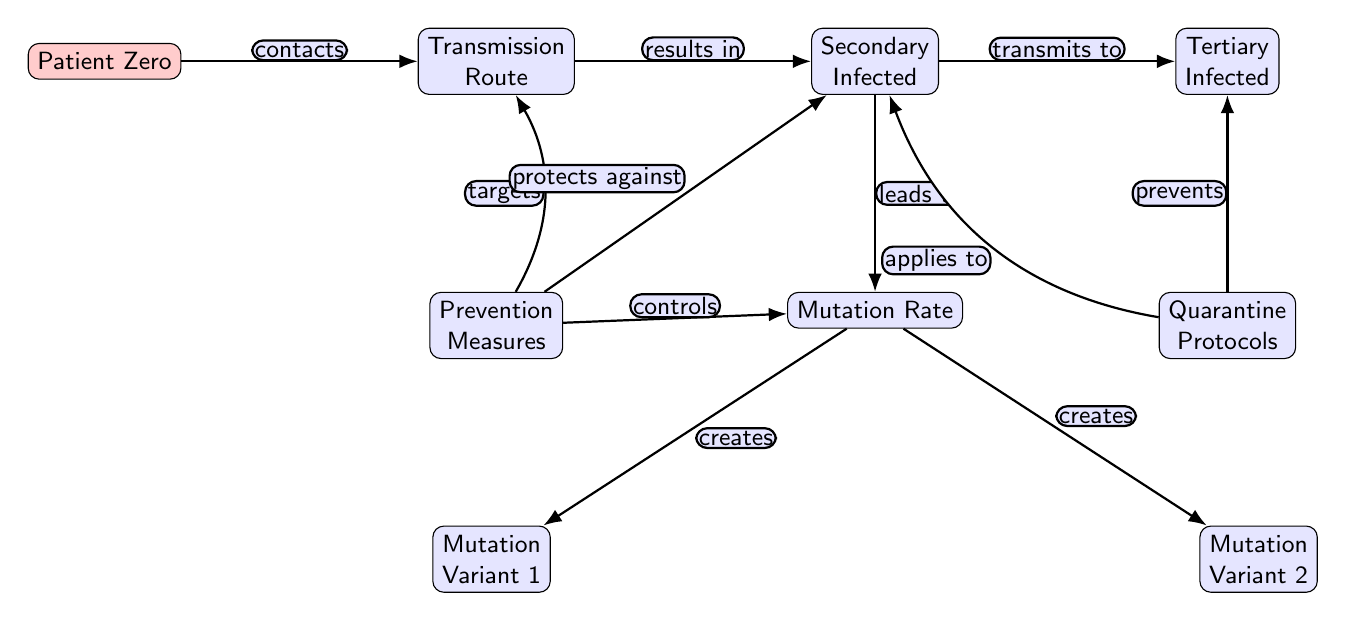What is the starting point of the transmission pathway? The diagram clearly identifies "Patient Zero" as the starting point by placing it at the far left. It is the first node in the diagram indicating the origin of the transmission pathway.
Answer: Patient Zero How many mutation variants are there in this diagram? The diagram shows two distinct mutation variants indicated as "Mutation Variant 1" and "Mutation Variant 2", both positioned below the "Mutation Rate" node. The count of these variants is the number displayed explicitly in the diagram.
Answer: 2 What does "Transmission Route" lead to? According to the diagram, "Transmission Route" directly results in "Secondary Infected," as indicated by the edge labeled "results in". This relationship is directly observable in the flow of the diagram.
Answer: Secondary Infected Which node is linked to "Quarantine Protocols"? The diagram indicates that "Quarantine Protocols" is linked to the "Tertiary Infected" node with the edge labeled "prevents". Following the logical path from "Quarantine Protocols" leads us directly to its associated node.
Answer: Tertiary Infected What do "Prevention Measures" target in the diagram? The diagram illustrates that "Prevention Measures" targets "Transmission Route". The edge labeled "targets" explicitly denotes this relationship, making it clear within the framework of the diagram.
Answer: Transmission Route How does the "Mutation Rate" interact with mutation variants? The "Mutation Rate" node leads to both "Mutation Variant 1" and "Mutation Variant 2" with edges labeled "creates". This indicates that the mutation rate is a precursor for the emergence of these variants.
Answer: Creates What is the relationship between "Secondary Infected" and "Tertiary Infected"? The relationship is established in the diagram through the edge labeled "transmits to", connecting "Secondary Infected" directly to "Tertiary Infected". This signifies how one leads to the other in the transmission pathway.
Answer: Transmits to What measures protect against "Secondary Infected"? The edge labeled "protects against" from "Prevention Measures" directly points to the "Secondary Infected" node. This indicates that the prevention measures in the diagram are specifically aimed at reducing the infection of secondary individuals.
Answer: Protects against What does "Mutation Rate" lead to? The "Mutation Rate" node is shown to lead to "Mutation Variant 1" and "Mutation Variant 2", indicating that both variants are products of the mutation process as shown in the diagram with edges labeled "creates".
Answer: Creates 